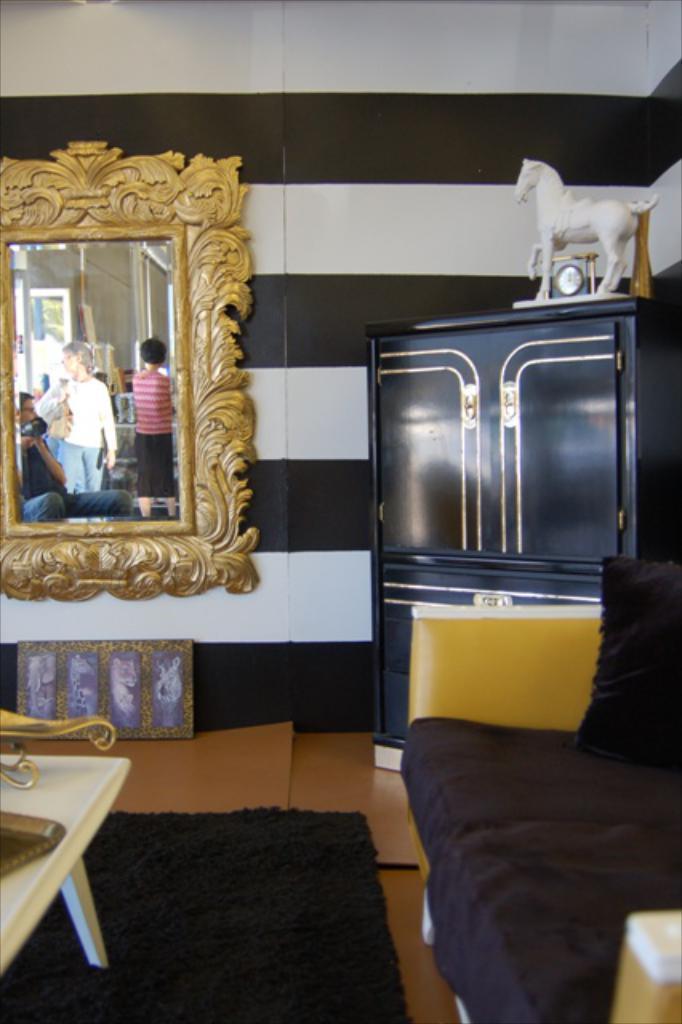Describe this image in one or two sentences. In this image I can see a sofa and a table. I can see a cupboard. There is a toy on the cupboard. I can see a mirror. At the bottom there is a carpet. 